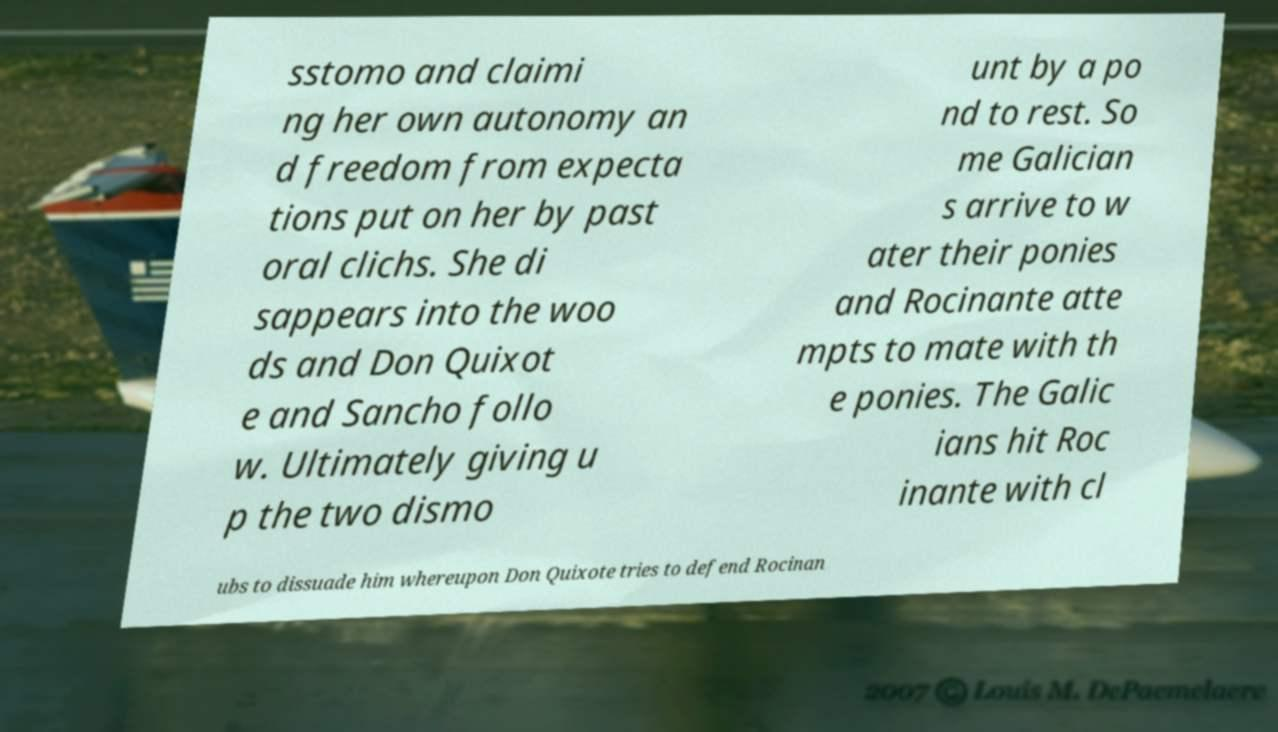There's text embedded in this image that I need extracted. Can you transcribe it verbatim? sstomo and claimi ng her own autonomy an d freedom from expecta tions put on her by past oral clichs. She di sappears into the woo ds and Don Quixot e and Sancho follo w. Ultimately giving u p the two dismo unt by a po nd to rest. So me Galician s arrive to w ater their ponies and Rocinante atte mpts to mate with th e ponies. The Galic ians hit Roc inante with cl ubs to dissuade him whereupon Don Quixote tries to defend Rocinan 